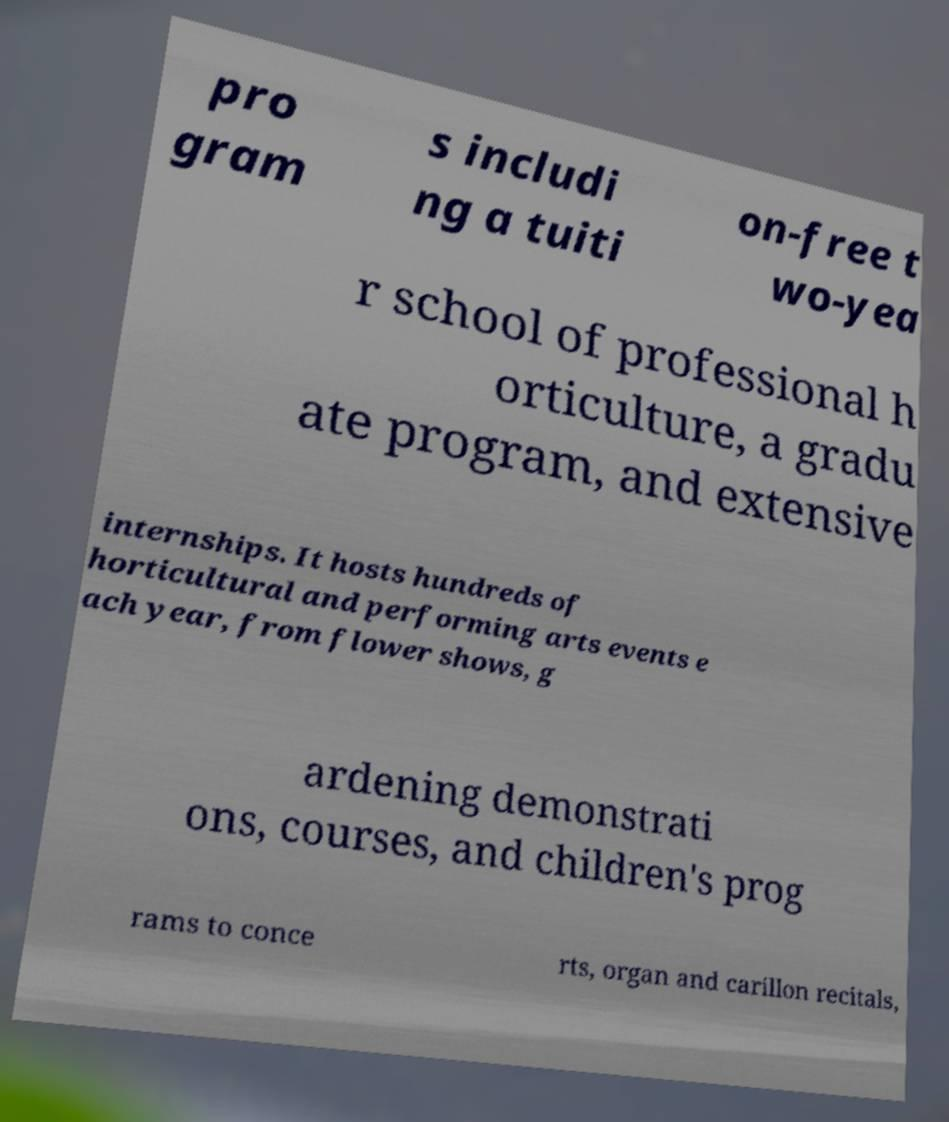Please read and relay the text visible in this image. What does it say? pro gram s includi ng a tuiti on-free t wo-yea r school of professional h orticulture, a gradu ate program, and extensive internships. It hosts hundreds of horticultural and performing arts events e ach year, from flower shows, g ardening demonstrati ons, courses, and children's prog rams to conce rts, organ and carillon recitals, 